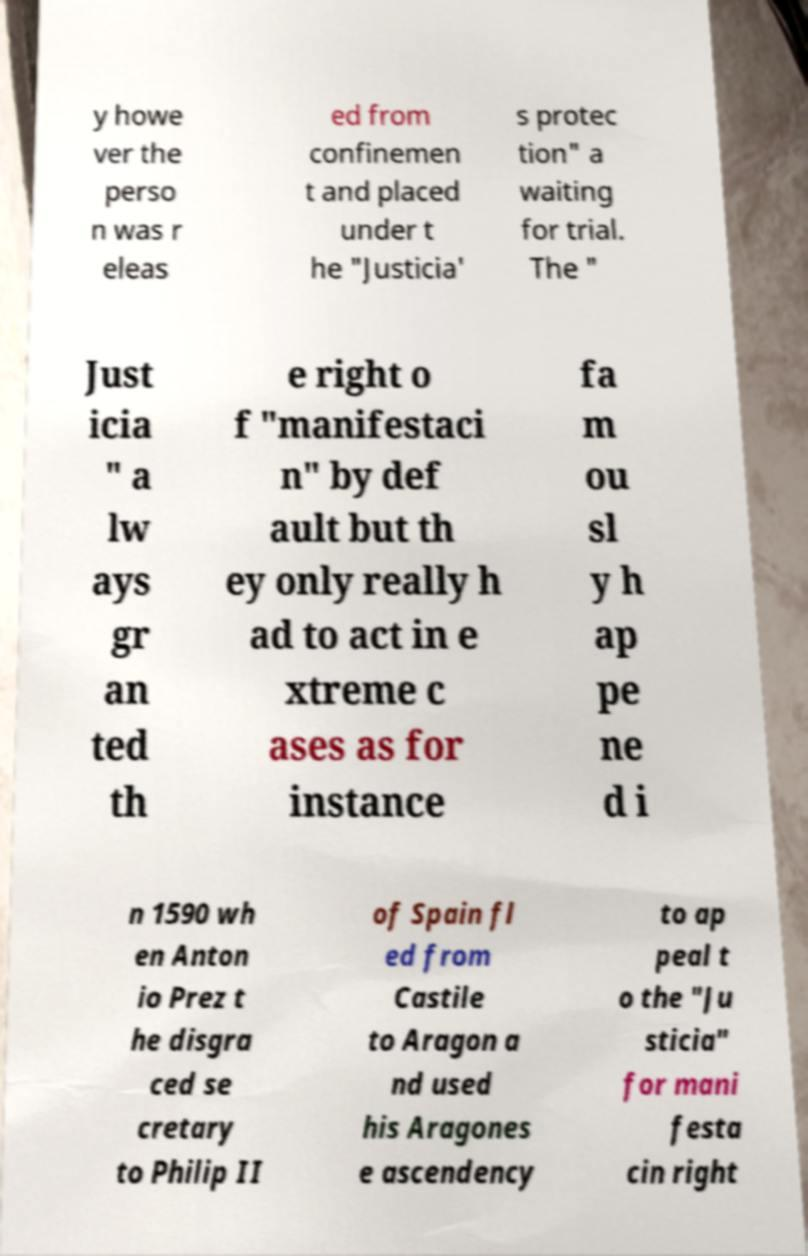There's text embedded in this image that I need extracted. Can you transcribe it verbatim? y howe ver the perso n was r eleas ed from confinemen t and placed under t he "Justicia' s protec tion" a waiting for trial. The " Just icia " a lw ays gr an ted th e right o f "manifestaci n" by def ault but th ey only really h ad to act in e xtreme c ases as for instance fa m ou sl y h ap pe ne d i n 1590 wh en Anton io Prez t he disgra ced se cretary to Philip II of Spain fl ed from Castile to Aragon a nd used his Aragones e ascendency to ap peal t o the "Ju sticia" for mani festa cin right 